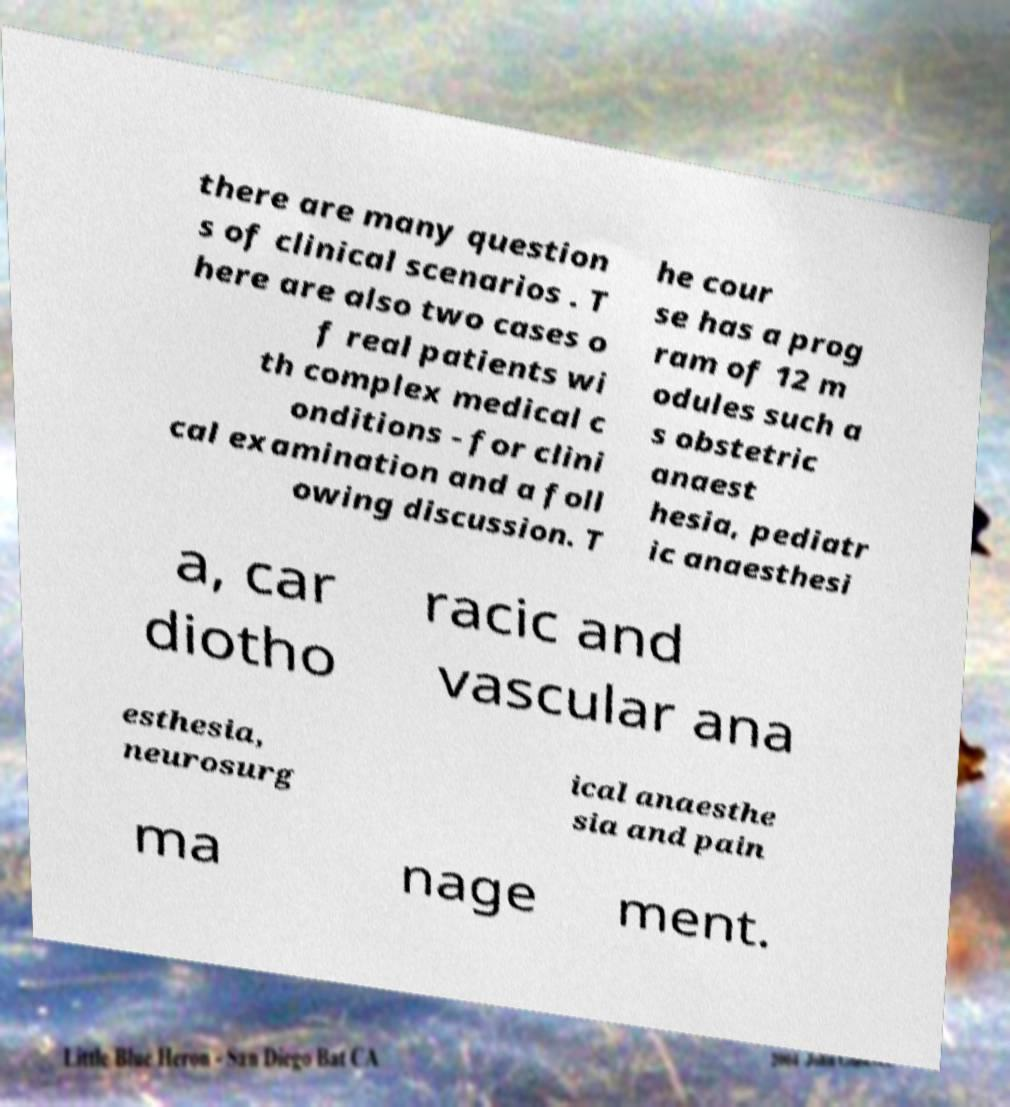For documentation purposes, I need the text within this image transcribed. Could you provide that? there are many question s of clinical scenarios . T here are also two cases o f real patients wi th complex medical c onditions - for clini cal examination and a foll owing discussion. T he cour se has a prog ram of 12 m odules such a s obstetric anaest hesia, pediatr ic anaesthesi a, car diotho racic and vascular ana esthesia, neurosurg ical anaesthe sia and pain ma nage ment. 